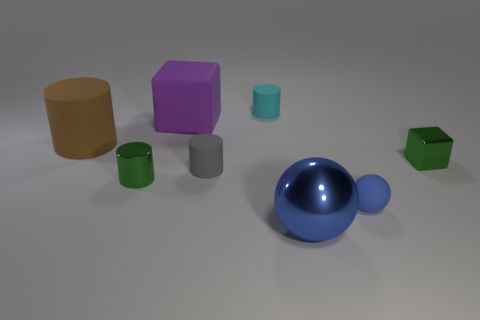There is another tiny ball that is the same color as the metallic ball; what material is it?
Your answer should be very brief. Rubber. What number of tiny matte objects have the same color as the shiny sphere?
Offer a very short reply. 1. What number of other objects are the same color as the tiny sphere?
Give a very brief answer. 1. Are there more small metallic cylinders than green objects?
Your response must be concise. No. What material is the green cube?
Offer a terse response. Metal. Do the blue metal sphere that is in front of the green cylinder and the small metal cylinder have the same size?
Your answer should be compact. No. There is a blue object to the right of the shiny sphere; what size is it?
Offer a terse response. Small. What number of tiny gray cylinders are there?
Your answer should be very brief. 1. Does the shiny cube have the same color as the tiny metal cylinder?
Ensure brevity in your answer.  Yes. There is a shiny object that is behind the tiny rubber ball and left of the small green metal cube; what is its color?
Ensure brevity in your answer.  Green. 